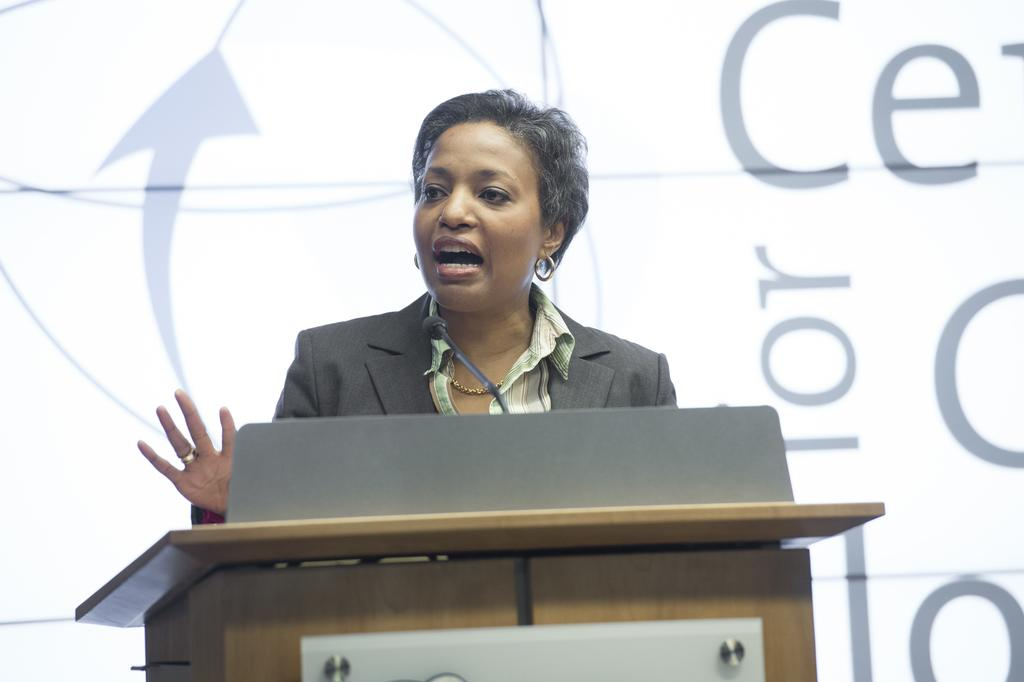Who is the main subject in the image? There is a woman in the image. What is the woman doing in the image? The woman is standing in front of a podium. What object is on the podium? There is a microphone on the podium. What can be seen in the background of the image? There is a banner in the background of the image. What type of jar is the woman holding in the image? There is no jar present in the image; the woman is standing in front of a podium with a microphone. 